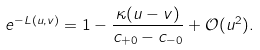Convert formula to latex. <formula><loc_0><loc_0><loc_500><loc_500>e ^ { - L ( u , v ) } = 1 - \frac { \kappa ( u - v ) } { c _ { + 0 } - c _ { - 0 } } + \mathcal { O } ( u ^ { 2 } ) .</formula> 